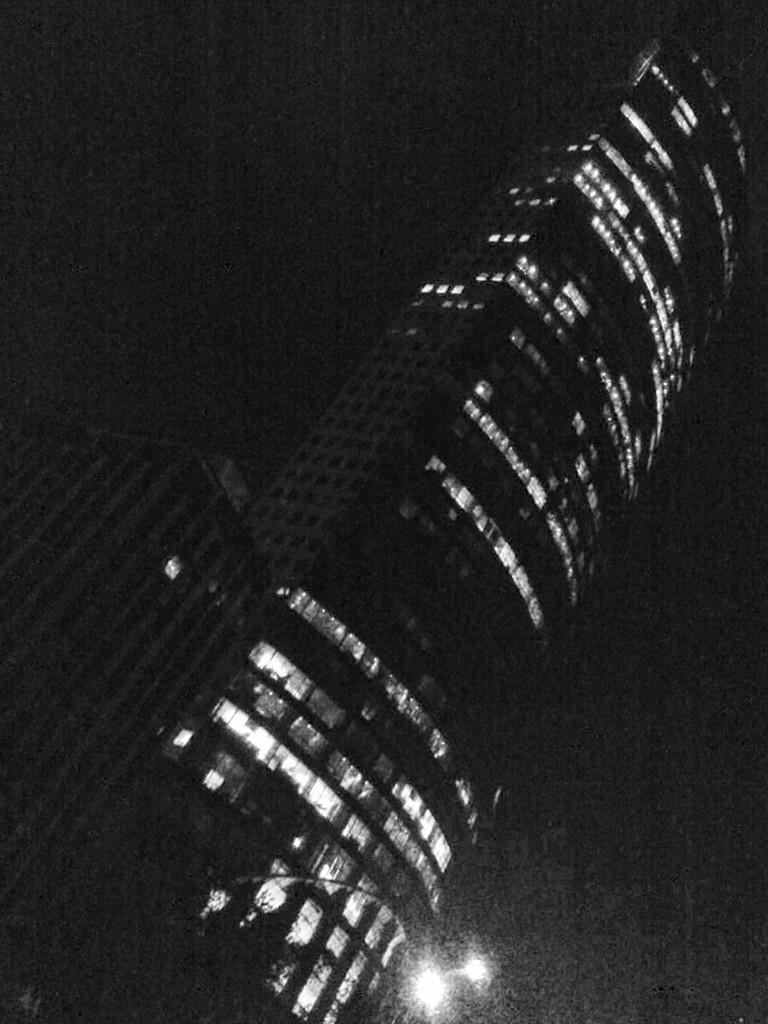Please provide a concise description of this image. In this image we can see buildings, windows, there is a light, also the background is dark. 